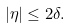<formula> <loc_0><loc_0><loc_500><loc_500>| \eta | \leq 2 \delta .</formula> 